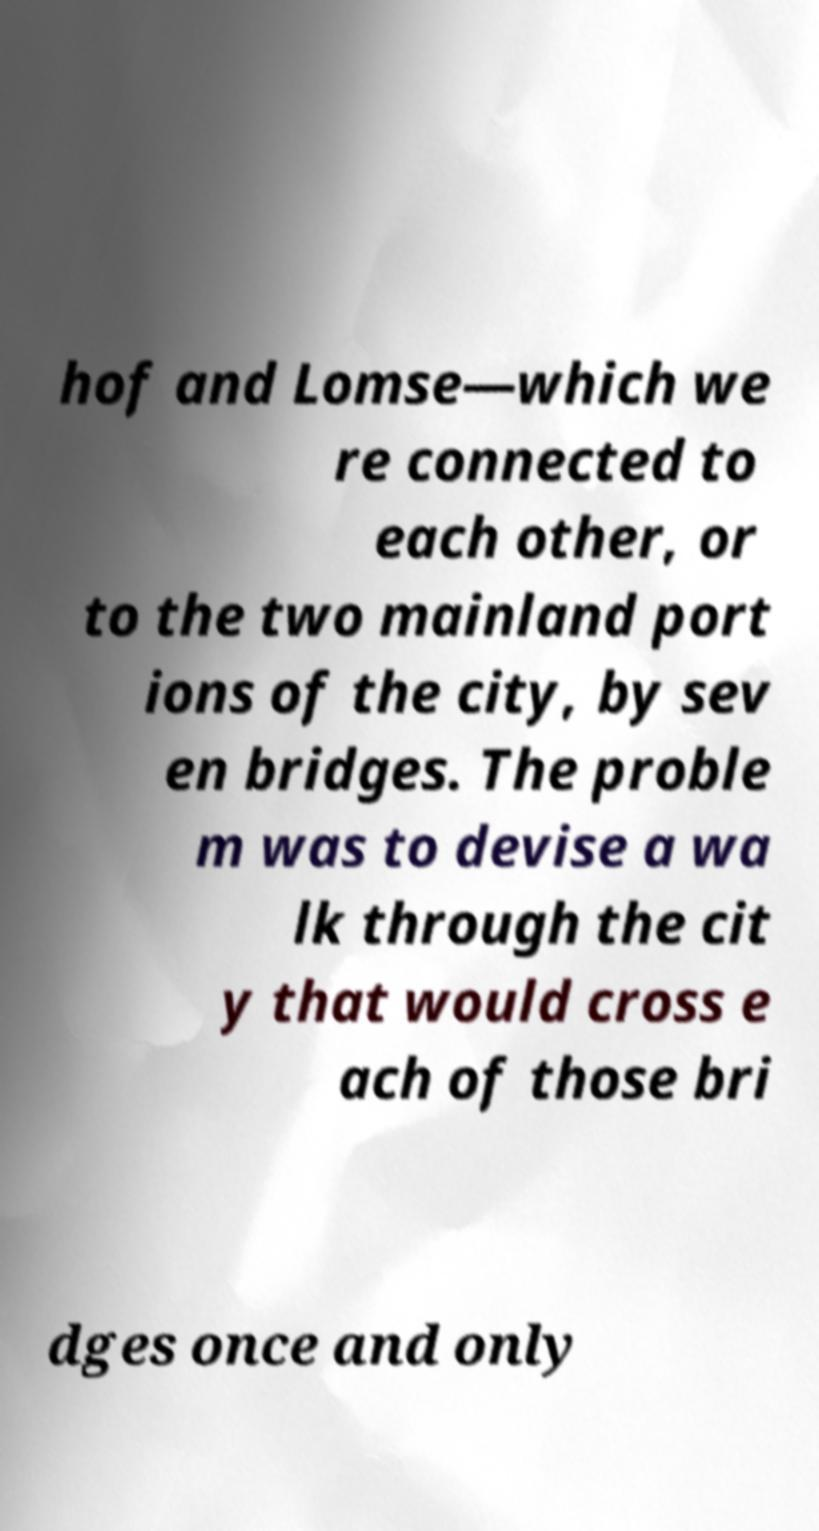Can you accurately transcribe the text from the provided image for me? hof and Lomse—which we re connected to each other, or to the two mainland port ions of the city, by sev en bridges. The proble m was to devise a wa lk through the cit y that would cross e ach of those bri dges once and only 